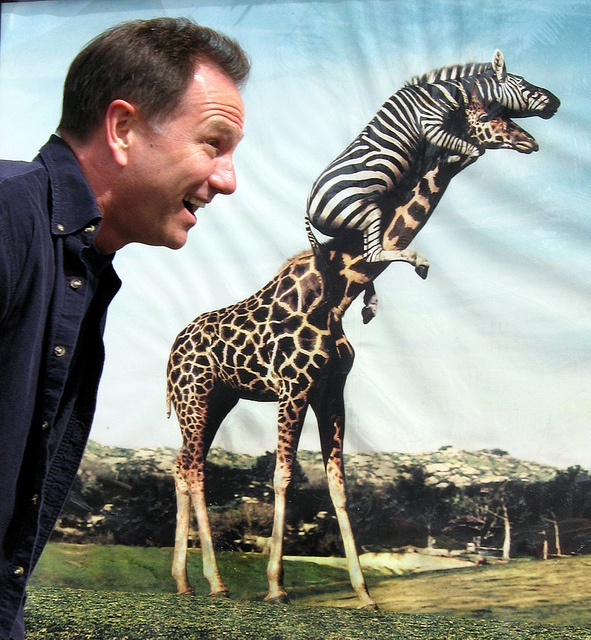Describe the objects in this image and their specific colors. I can see people in black, maroon, and brown tones, giraffe in black, tan, gray, and maroon tones, and zebra in black, ivory, gray, and darkgray tones in this image. 